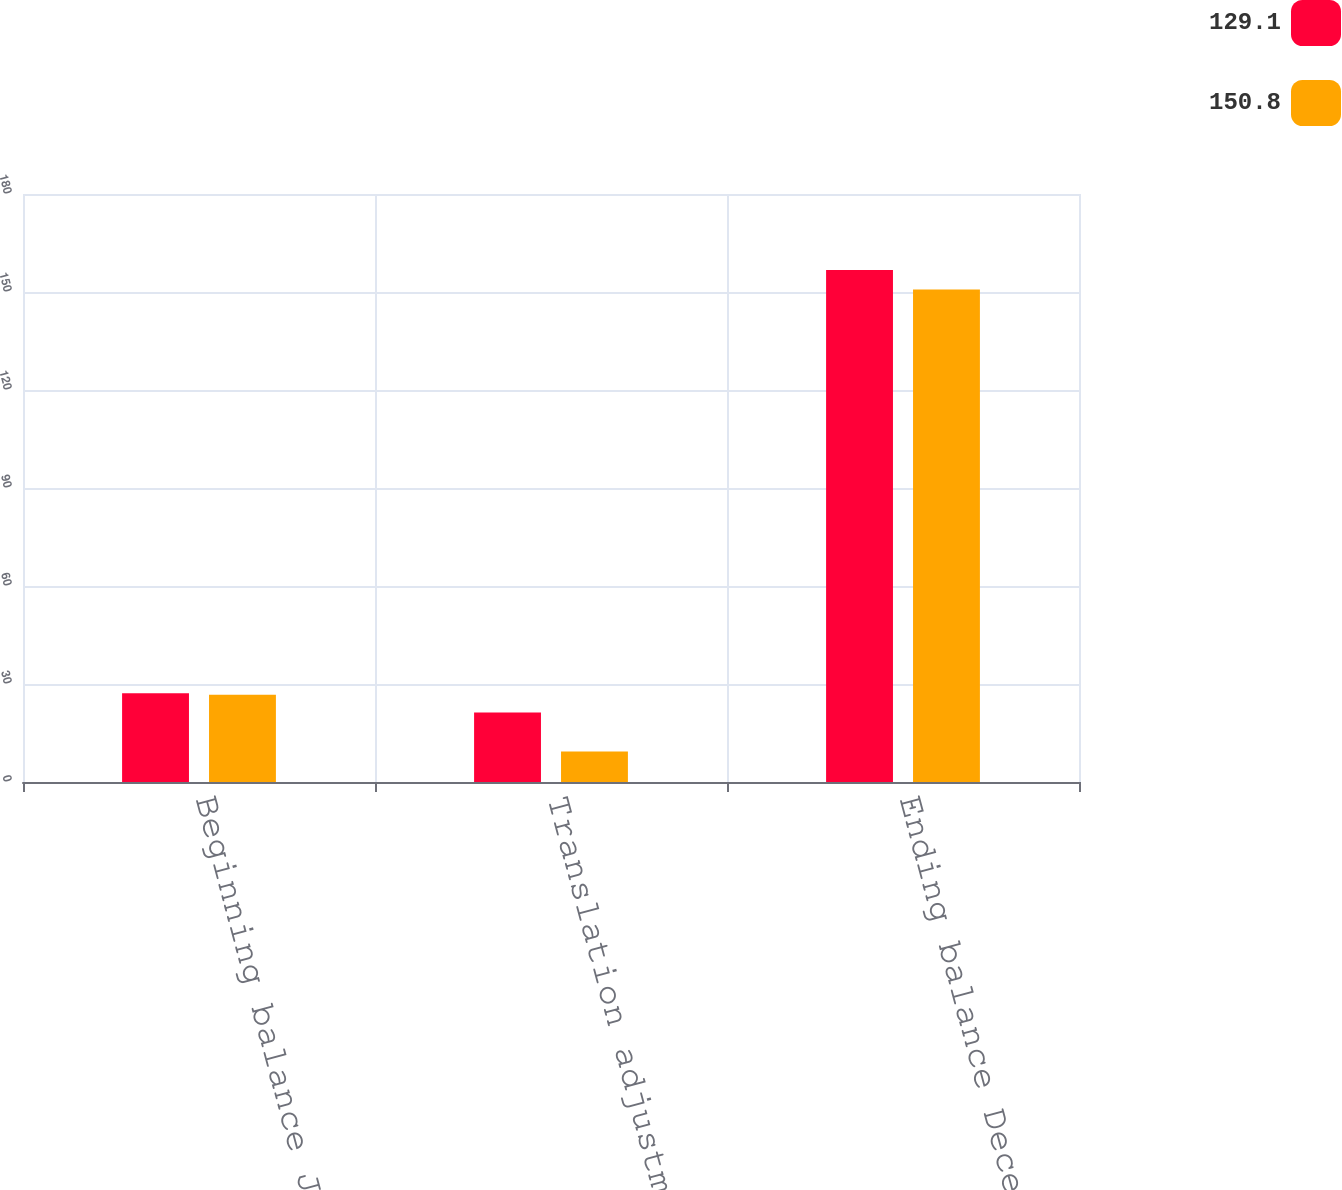Convert chart. <chart><loc_0><loc_0><loc_500><loc_500><stacked_bar_chart><ecel><fcel>Beginning balance January 1<fcel>Translation adjustment<fcel>Ending balance December 31<nl><fcel>129.1<fcel>27.2<fcel>21.3<fcel>156.7<nl><fcel>150.8<fcel>26.7<fcel>9.3<fcel>150.8<nl></chart> 